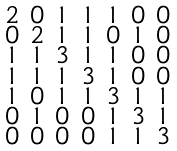<formula> <loc_0><loc_0><loc_500><loc_500>\begin{smallmatrix} 2 & 0 & 1 & 1 & 1 & 0 & 0 \\ 0 & 2 & 1 & 1 & 0 & 1 & 0 \\ 1 & 1 & 3 & 1 & 1 & 0 & 0 \\ 1 & 1 & 1 & 3 & 1 & 0 & 0 \\ 1 & 0 & 1 & 1 & 3 & 1 & 1 \\ 0 & 1 & 0 & 0 & 1 & 3 & 1 \\ 0 & 0 & 0 & 0 & 1 & 1 & 3 \end{smallmatrix}</formula> 